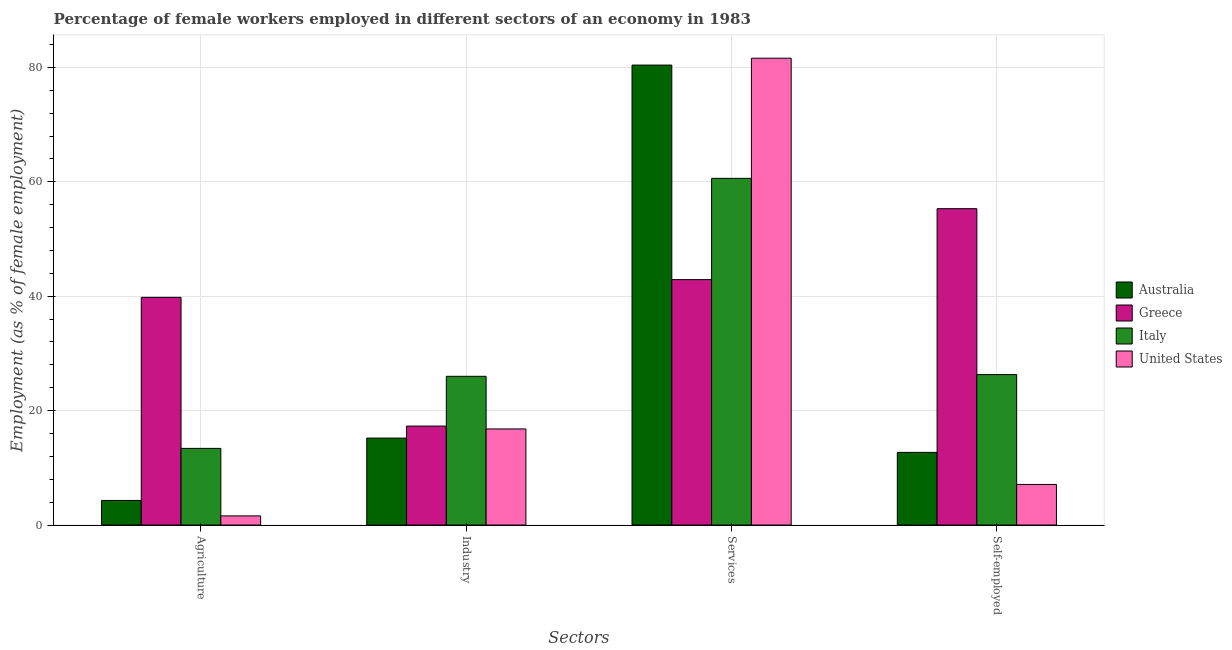How many bars are there on the 2nd tick from the right?
Provide a short and direct response. 4. What is the label of the 1st group of bars from the left?
Make the answer very short. Agriculture. What is the percentage of female workers in services in Greece?
Provide a short and direct response. 42.9. Across all countries, what is the maximum percentage of female workers in services?
Keep it short and to the point. 81.6. Across all countries, what is the minimum percentage of self employed female workers?
Keep it short and to the point. 7.1. In which country was the percentage of female workers in services maximum?
Your response must be concise. United States. In which country was the percentage of self employed female workers minimum?
Provide a short and direct response. United States. What is the total percentage of female workers in services in the graph?
Your answer should be compact. 265.5. What is the difference between the percentage of self employed female workers in Italy and that in Australia?
Your answer should be compact. 13.6. What is the difference between the percentage of self employed female workers in Australia and the percentage of female workers in agriculture in United States?
Offer a terse response. 11.1. What is the average percentage of female workers in agriculture per country?
Provide a short and direct response. 14.77. What is the difference between the percentage of female workers in agriculture and percentage of female workers in services in Italy?
Give a very brief answer. -47.2. What is the ratio of the percentage of self employed female workers in Greece to that in Italy?
Your answer should be compact. 2.1. Is the percentage of female workers in agriculture in Italy less than that in Greece?
Offer a very short reply. Yes. What is the difference between the highest and the second highest percentage of female workers in services?
Provide a short and direct response. 1.2. What is the difference between the highest and the lowest percentage of self employed female workers?
Keep it short and to the point. 48.2. In how many countries, is the percentage of self employed female workers greater than the average percentage of self employed female workers taken over all countries?
Provide a succinct answer. 2. What does the 2nd bar from the right in Agriculture represents?
Your answer should be compact. Italy. Is it the case that in every country, the sum of the percentage of female workers in agriculture and percentage of female workers in industry is greater than the percentage of female workers in services?
Your answer should be very brief. No. How many bars are there?
Your answer should be very brief. 16. How many countries are there in the graph?
Provide a short and direct response. 4. What is the difference between two consecutive major ticks on the Y-axis?
Offer a terse response. 20. Does the graph contain any zero values?
Your response must be concise. No. What is the title of the graph?
Your answer should be compact. Percentage of female workers employed in different sectors of an economy in 1983. What is the label or title of the X-axis?
Offer a very short reply. Sectors. What is the label or title of the Y-axis?
Ensure brevity in your answer.  Employment (as % of female employment). What is the Employment (as % of female employment) of Australia in Agriculture?
Your response must be concise. 4.3. What is the Employment (as % of female employment) of Greece in Agriculture?
Offer a terse response. 39.8. What is the Employment (as % of female employment) in Italy in Agriculture?
Make the answer very short. 13.4. What is the Employment (as % of female employment) in United States in Agriculture?
Your answer should be very brief. 1.6. What is the Employment (as % of female employment) of Australia in Industry?
Your answer should be compact. 15.2. What is the Employment (as % of female employment) of Greece in Industry?
Offer a terse response. 17.3. What is the Employment (as % of female employment) in United States in Industry?
Give a very brief answer. 16.8. What is the Employment (as % of female employment) in Australia in Services?
Ensure brevity in your answer.  80.4. What is the Employment (as % of female employment) in Greece in Services?
Your answer should be very brief. 42.9. What is the Employment (as % of female employment) in Italy in Services?
Ensure brevity in your answer.  60.6. What is the Employment (as % of female employment) of United States in Services?
Provide a succinct answer. 81.6. What is the Employment (as % of female employment) of Australia in Self-employed?
Your answer should be compact. 12.7. What is the Employment (as % of female employment) of Greece in Self-employed?
Your answer should be compact. 55.3. What is the Employment (as % of female employment) of Italy in Self-employed?
Make the answer very short. 26.3. What is the Employment (as % of female employment) of United States in Self-employed?
Keep it short and to the point. 7.1. Across all Sectors, what is the maximum Employment (as % of female employment) in Australia?
Give a very brief answer. 80.4. Across all Sectors, what is the maximum Employment (as % of female employment) in Greece?
Give a very brief answer. 55.3. Across all Sectors, what is the maximum Employment (as % of female employment) in Italy?
Keep it short and to the point. 60.6. Across all Sectors, what is the maximum Employment (as % of female employment) in United States?
Your answer should be very brief. 81.6. Across all Sectors, what is the minimum Employment (as % of female employment) in Australia?
Give a very brief answer. 4.3. Across all Sectors, what is the minimum Employment (as % of female employment) in Greece?
Make the answer very short. 17.3. Across all Sectors, what is the minimum Employment (as % of female employment) of Italy?
Provide a short and direct response. 13.4. Across all Sectors, what is the minimum Employment (as % of female employment) in United States?
Your response must be concise. 1.6. What is the total Employment (as % of female employment) in Australia in the graph?
Keep it short and to the point. 112.6. What is the total Employment (as % of female employment) in Greece in the graph?
Make the answer very short. 155.3. What is the total Employment (as % of female employment) of Italy in the graph?
Your answer should be compact. 126.3. What is the total Employment (as % of female employment) in United States in the graph?
Provide a succinct answer. 107.1. What is the difference between the Employment (as % of female employment) in United States in Agriculture and that in Industry?
Your answer should be compact. -15.2. What is the difference between the Employment (as % of female employment) in Australia in Agriculture and that in Services?
Keep it short and to the point. -76.1. What is the difference between the Employment (as % of female employment) of Italy in Agriculture and that in Services?
Provide a short and direct response. -47.2. What is the difference between the Employment (as % of female employment) in United States in Agriculture and that in Services?
Provide a short and direct response. -80. What is the difference between the Employment (as % of female employment) in Greece in Agriculture and that in Self-employed?
Your answer should be very brief. -15.5. What is the difference between the Employment (as % of female employment) in Italy in Agriculture and that in Self-employed?
Your response must be concise. -12.9. What is the difference between the Employment (as % of female employment) in United States in Agriculture and that in Self-employed?
Your response must be concise. -5.5. What is the difference between the Employment (as % of female employment) of Australia in Industry and that in Services?
Give a very brief answer. -65.2. What is the difference between the Employment (as % of female employment) of Greece in Industry and that in Services?
Your answer should be compact. -25.6. What is the difference between the Employment (as % of female employment) of Italy in Industry and that in Services?
Give a very brief answer. -34.6. What is the difference between the Employment (as % of female employment) of United States in Industry and that in Services?
Offer a terse response. -64.8. What is the difference between the Employment (as % of female employment) in Australia in Industry and that in Self-employed?
Your answer should be compact. 2.5. What is the difference between the Employment (as % of female employment) of Greece in Industry and that in Self-employed?
Ensure brevity in your answer.  -38. What is the difference between the Employment (as % of female employment) of Australia in Services and that in Self-employed?
Give a very brief answer. 67.7. What is the difference between the Employment (as % of female employment) of Italy in Services and that in Self-employed?
Ensure brevity in your answer.  34.3. What is the difference between the Employment (as % of female employment) of United States in Services and that in Self-employed?
Offer a terse response. 74.5. What is the difference between the Employment (as % of female employment) of Australia in Agriculture and the Employment (as % of female employment) of Italy in Industry?
Your answer should be very brief. -21.7. What is the difference between the Employment (as % of female employment) in Greece in Agriculture and the Employment (as % of female employment) in Italy in Industry?
Your response must be concise. 13.8. What is the difference between the Employment (as % of female employment) in Australia in Agriculture and the Employment (as % of female employment) in Greece in Services?
Offer a terse response. -38.6. What is the difference between the Employment (as % of female employment) in Australia in Agriculture and the Employment (as % of female employment) in Italy in Services?
Offer a terse response. -56.3. What is the difference between the Employment (as % of female employment) in Australia in Agriculture and the Employment (as % of female employment) in United States in Services?
Your answer should be compact. -77.3. What is the difference between the Employment (as % of female employment) of Greece in Agriculture and the Employment (as % of female employment) of Italy in Services?
Your answer should be very brief. -20.8. What is the difference between the Employment (as % of female employment) of Greece in Agriculture and the Employment (as % of female employment) of United States in Services?
Keep it short and to the point. -41.8. What is the difference between the Employment (as % of female employment) of Italy in Agriculture and the Employment (as % of female employment) of United States in Services?
Give a very brief answer. -68.2. What is the difference between the Employment (as % of female employment) in Australia in Agriculture and the Employment (as % of female employment) in Greece in Self-employed?
Give a very brief answer. -51. What is the difference between the Employment (as % of female employment) of Australia in Agriculture and the Employment (as % of female employment) of Italy in Self-employed?
Provide a short and direct response. -22. What is the difference between the Employment (as % of female employment) of Australia in Agriculture and the Employment (as % of female employment) of United States in Self-employed?
Make the answer very short. -2.8. What is the difference between the Employment (as % of female employment) in Greece in Agriculture and the Employment (as % of female employment) in United States in Self-employed?
Keep it short and to the point. 32.7. What is the difference between the Employment (as % of female employment) in Italy in Agriculture and the Employment (as % of female employment) in United States in Self-employed?
Ensure brevity in your answer.  6.3. What is the difference between the Employment (as % of female employment) of Australia in Industry and the Employment (as % of female employment) of Greece in Services?
Give a very brief answer. -27.7. What is the difference between the Employment (as % of female employment) of Australia in Industry and the Employment (as % of female employment) of Italy in Services?
Offer a terse response. -45.4. What is the difference between the Employment (as % of female employment) in Australia in Industry and the Employment (as % of female employment) in United States in Services?
Your answer should be very brief. -66.4. What is the difference between the Employment (as % of female employment) of Greece in Industry and the Employment (as % of female employment) of Italy in Services?
Your answer should be very brief. -43.3. What is the difference between the Employment (as % of female employment) in Greece in Industry and the Employment (as % of female employment) in United States in Services?
Your response must be concise. -64.3. What is the difference between the Employment (as % of female employment) of Italy in Industry and the Employment (as % of female employment) of United States in Services?
Your answer should be compact. -55.6. What is the difference between the Employment (as % of female employment) of Australia in Industry and the Employment (as % of female employment) of Greece in Self-employed?
Ensure brevity in your answer.  -40.1. What is the difference between the Employment (as % of female employment) of Australia in Industry and the Employment (as % of female employment) of Italy in Self-employed?
Provide a succinct answer. -11.1. What is the difference between the Employment (as % of female employment) in Australia in Industry and the Employment (as % of female employment) in United States in Self-employed?
Give a very brief answer. 8.1. What is the difference between the Employment (as % of female employment) in Italy in Industry and the Employment (as % of female employment) in United States in Self-employed?
Make the answer very short. 18.9. What is the difference between the Employment (as % of female employment) of Australia in Services and the Employment (as % of female employment) of Greece in Self-employed?
Offer a terse response. 25.1. What is the difference between the Employment (as % of female employment) of Australia in Services and the Employment (as % of female employment) of Italy in Self-employed?
Make the answer very short. 54.1. What is the difference between the Employment (as % of female employment) of Australia in Services and the Employment (as % of female employment) of United States in Self-employed?
Ensure brevity in your answer.  73.3. What is the difference between the Employment (as % of female employment) in Greece in Services and the Employment (as % of female employment) in Italy in Self-employed?
Provide a succinct answer. 16.6. What is the difference between the Employment (as % of female employment) of Greece in Services and the Employment (as % of female employment) of United States in Self-employed?
Offer a terse response. 35.8. What is the difference between the Employment (as % of female employment) of Italy in Services and the Employment (as % of female employment) of United States in Self-employed?
Provide a succinct answer. 53.5. What is the average Employment (as % of female employment) of Australia per Sectors?
Your response must be concise. 28.15. What is the average Employment (as % of female employment) in Greece per Sectors?
Provide a succinct answer. 38.83. What is the average Employment (as % of female employment) in Italy per Sectors?
Provide a short and direct response. 31.57. What is the average Employment (as % of female employment) in United States per Sectors?
Your response must be concise. 26.77. What is the difference between the Employment (as % of female employment) of Australia and Employment (as % of female employment) of Greece in Agriculture?
Ensure brevity in your answer.  -35.5. What is the difference between the Employment (as % of female employment) of Australia and Employment (as % of female employment) of Italy in Agriculture?
Give a very brief answer. -9.1. What is the difference between the Employment (as % of female employment) in Australia and Employment (as % of female employment) in United States in Agriculture?
Offer a very short reply. 2.7. What is the difference between the Employment (as % of female employment) of Greece and Employment (as % of female employment) of Italy in Agriculture?
Provide a short and direct response. 26.4. What is the difference between the Employment (as % of female employment) in Greece and Employment (as % of female employment) in United States in Agriculture?
Your answer should be very brief. 38.2. What is the difference between the Employment (as % of female employment) in Australia and Employment (as % of female employment) in Greece in Industry?
Provide a succinct answer. -2.1. What is the difference between the Employment (as % of female employment) of Australia and Employment (as % of female employment) of Italy in Industry?
Your response must be concise. -10.8. What is the difference between the Employment (as % of female employment) in Italy and Employment (as % of female employment) in United States in Industry?
Keep it short and to the point. 9.2. What is the difference between the Employment (as % of female employment) of Australia and Employment (as % of female employment) of Greece in Services?
Offer a very short reply. 37.5. What is the difference between the Employment (as % of female employment) in Australia and Employment (as % of female employment) in Italy in Services?
Your response must be concise. 19.8. What is the difference between the Employment (as % of female employment) in Greece and Employment (as % of female employment) in Italy in Services?
Your response must be concise. -17.7. What is the difference between the Employment (as % of female employment) of Greece and Employment (as % of female employment) of United States in Services?
Provide a succinct answer. -38.7. What is the difference between the Employment (as % of female employment) of Italy and Employment (as % of female employment) of United States in Services?
Keep it short and to the point. -21. What is the difference between the Employment (as % of female employment) of Australia and Employment (as % of female employment) of Greece in Self-employed?
Your response must be concise. -42.6. What is the difference between the Employment (as % of female employment) of Australia and Employment (as % of female employment) of Italy in Self-employed?
Your answer should be compact. -13.6. What is the difference between the Employment (as % of female employment) of Australia and Employment (as % of female employment) of United States in Self-employed?
Offer a very short reply. 5.6. What is the difference between the Employment (as % of female employment) of Greece and Employment (as % of female employment) of Italy in Self-employed?
Provide a short and direct response. 29. What is the difference between the Employment (as % of female employment) in Greece and Employment (as % of female employment) in United States in Self-employed?
Provide a succinct answer. 48.2. What is the ratio of the Employment (as % of female employment) of Australia in Agriculture to that in Industry?
Offer a very short reply. 0.28. What is the ratio of the Employment (as % of female employment) of Greece in Agriculture to that in Industry?
Keep it short and to the point. 2.3. What is the ratio of the Employment (as % of female employment) in Italy in Agriculture to that in Industry?
Provide a succinct answer. 0.52. What is the ratio of the Employment (as % of female employment) in United States in Agriculture to that in Industry?
Keep it short and to the point. 0.1. What is the ratio of the Employment (as % of female employment) in Australia in Agriculture to that in Services?
Your response must be concise. 0.05. What is the ratio of the Employment (as % of female employment) in Greece in Agriculture to that in Services?
Provide a succinct answer. 0.93. What is the ratio of the Employment (as % of female employment) of Italy in Agriculture to that in Services?
Ensure brevity in your answer.  0.22. What is the ratio of the Employment (as % of female employment) in United States in Agriculture to that in Services?
Offer a very short reply. 0.02. What is the ratio of the Employment (as % of female employment) of Australia in Agriculture to that in Self-employed?
Ensure brevity in your answer.  0.34. What is the ratio of the Employment (as % of female employment) in Greece in Agriculture to that in Self-employed?
Ensure brevity in your answer.  0.72. What is the ratio of the Employment (as % of female employment) in Italy in Agriculture to that in Self-employed?
Offer a terse response. 0.51. What is the ratio of the Employment (as % of female employment) of United States in Agriculture to that in Self-employed?
Keep it short and to the point. 0.23. What is the ratio of the Employment (as % of female employment) of Australia in Industry to that in Services?
Your answer should be very brief. 0.19. What is the ratio of the Employment (as % of female employment) in Greece in Industry to that in Services?
Your response must be concise. 0.4. What is the ratio of the Employment (as % of female employment) in Italy in Industry to that in Services?
Provide a short and direct response. 0.43. What is the ratio of the Employment (as % of female employment) of United States in Industry to that in Services?
Your answer should be very brief. 0.21. What is the ratio of the Employment (as % of female employment) of Australia in Industry to that in Self-employed?
Your answer should be very brief. 1.2. What is the ratio of the Employment (as % of female employment) in Greece in Industry to that in Self-employed?
Ensure brevity in your answer.  0.31. What is the ratio of the Employment (as % of female employment) of United States in Industry to that in Self-employed?
Your answer should be compact. 2.37. What is the ratio of the Employment (as % of female employment) of Australia in Services to that in Self-employed?
Your response must be concise. 6.33. What is the ratio of the Employment (as % of female employment) in Greece in Services to that in Self-employed?
Make the answer very short. 0.78. What is the ratio of the Employment (as % of female employment) in Italy in Services to that in Self-employed?
Offer a very short reply. 2.3. What is the ratio of the Employment (as % of female employment) in United States in Services to that in Self-employed?
Offer a terse response. 11.49. What is the difference between the highest and the second highest Employment (as % of female employment) in Australia?
Your response must be concise. 65.2. What is the difference between the highest and the second highest Employment (as % of female employment) of Italy?
Provide a short and direct response. 34.3. What is the difference between the highest and the second highest Employment (as % of female employment) in United States?
Offer a terse response. 64.8. What is the difference between the highest and the lowest Employment (as % of female employment) in Australia?
Your response must be concise. 76.1. What is the difference between the highest and the lowest Employment (as % of female employment) of Greece?
Give a very brief answer. 38. What is the difference between the highest and the lowest Employment (as % of female employment) in Italy?
Keep it short and to the point. 47.2. 